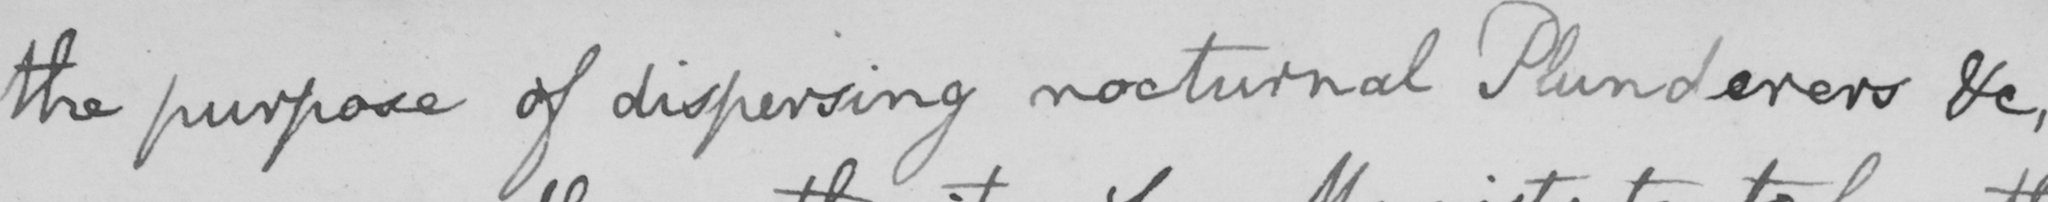What does this handwritten line say? the purpose of dispersing nocturnal Plunderers , &c , 